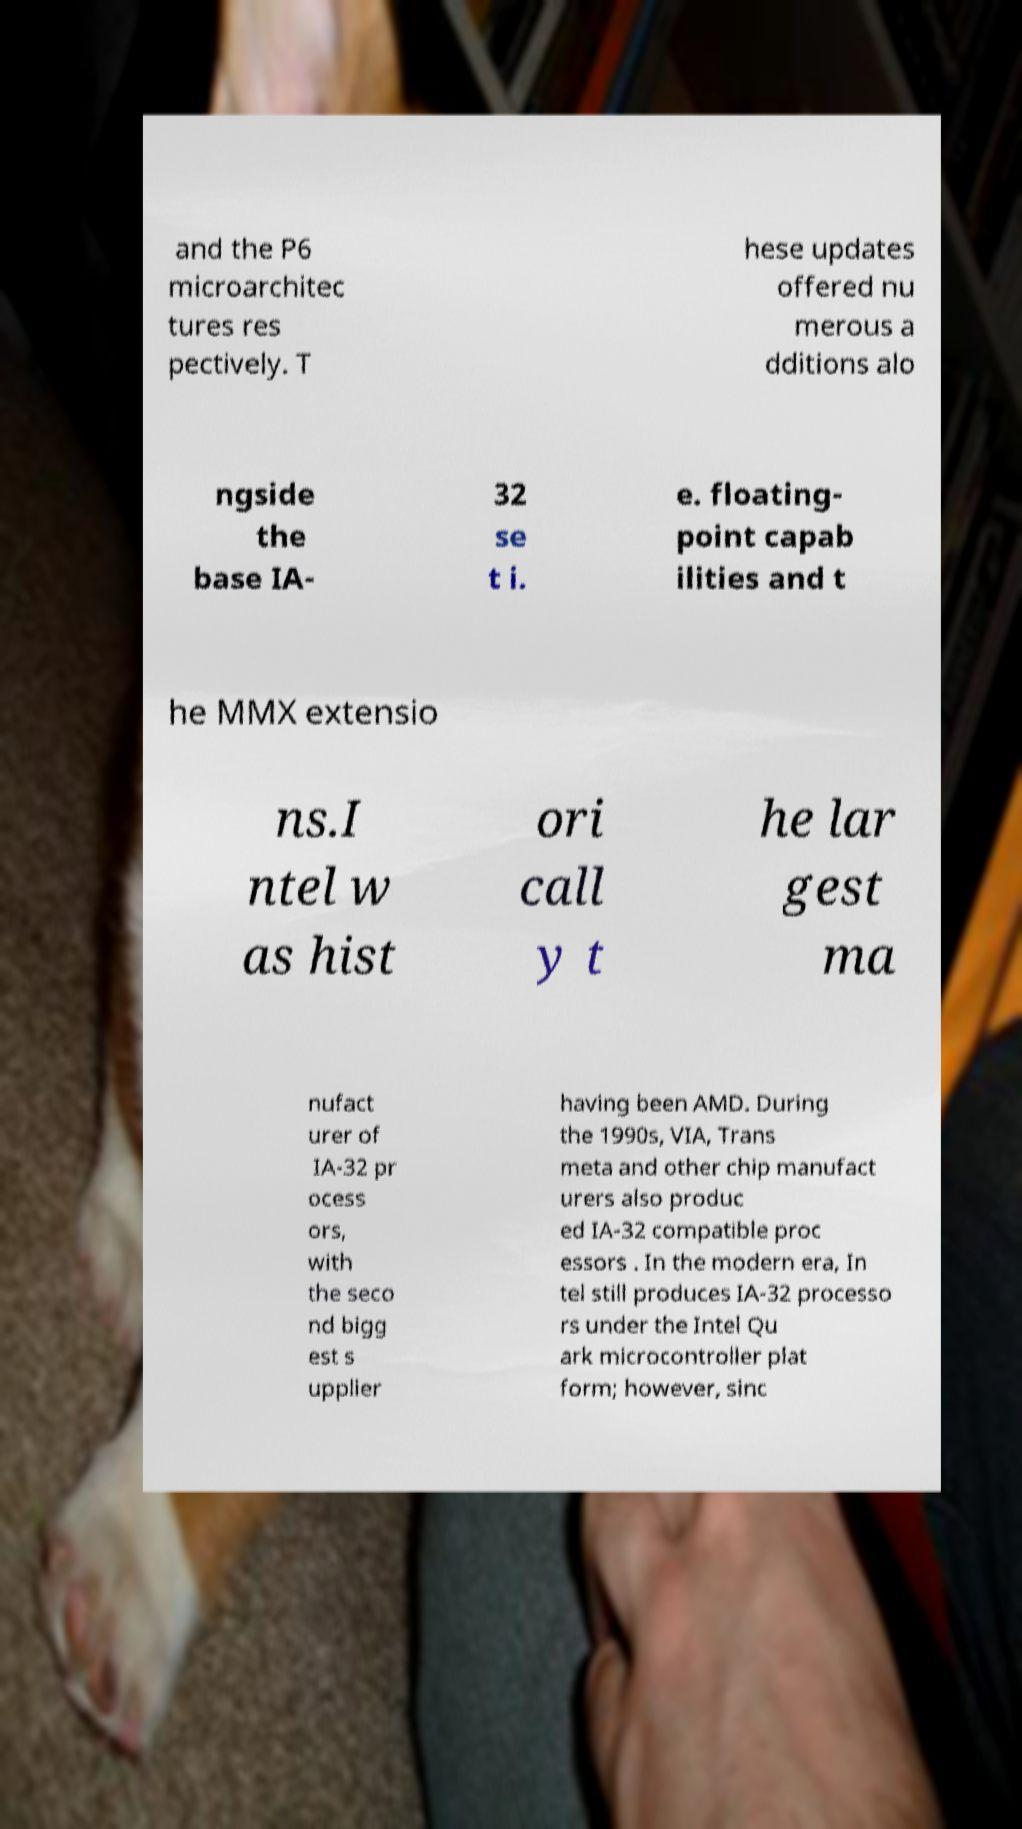Please identify and transcribe the text found in this image. and the P6 microarchitec tures res pectively. T hese updates offered nu merous a dditions alo ngside the base IA- 32 se t i. e. floating- point capab ilities and t he MMX extensio ns.I ntel w as hist ori call y t he lar gest ma nufact urer of IA-32 pr ocess ors, with the seco nd bigg est s upplier having been AMD. During the 1990s, VIA, Trans meta and other chip manufact urers also produc ed IA-32 compatible proc essors . In the modern era, In tel still produces IA-32 processo rs under the Intel Qu ark microcontroller plat form; however, sinc 